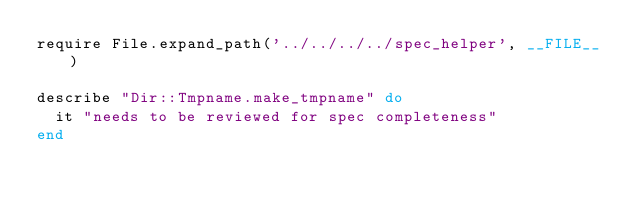<code> <loc_0><loc_0><loc_500><loc_500><_Ruby_>require File.expand_path('../../../../spec_helper', __FILE__)

describe "Dir::Tmpname.make_tmpname" do
  it "needs to be reviewed for spec completeness"
end
</code> 